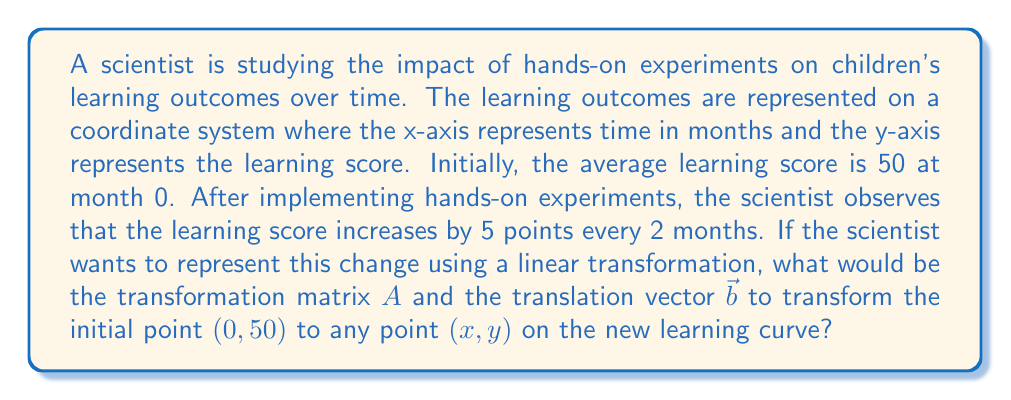Solve this math problem. Let's approach this step-by-step:

1) The general form of a linear transformation with translation is:

   $\begin{pmatrix} x' \\ y' \end{pmatrix} = A\begin{pmatrix} x \\ y \end{pmatrix} + \vec{b}$

   where $A$ is the transformation matrix and $\vec{b}$ is the translation vector.

2) We need to find the equation of the line representing the learning curve. We know:
   - The initial point is $(0, 50)$
   - The score increases by 5 points every 2 months

3) This gives us a slope of $\frac{5}{2} = 2.5$ points per month.

4) The equation of the line is therefore:
   $y = 2.5x + 50$

5) To represent this as a linear transformation:
   $\begin{pmatrix} x' \\ y' \end{pmatrix} = \begin{pmatrix} 1 & 0 \\ 2.5 & 1 \end{pmatrix}\begin{pmatrix} x \\ y \end{pmatrix} + \begin{pmatrix} 0 \\ 50 \end{pmatrix}$

6) Here's why:
   - The $x$ coordinate remains unchanged, so the first row of $A$ is $(1, 0)$
   - The $y$ coordinate increases by $2.5x$, so the second row of $A$ is $(2.5, 1)$
   - The initial $y$-intercept is 50, so $\vec{b} = (0, 50)$

Therefore, the transformation matrix $A$ and translation vector $\vec{b}$ are:

$A = \begin{pmatrix} 1 & 0 \\ 2.5 & 1 \end{pmatrix}$ and $\vec{b} = \begin{pmatrix} 0 \\ 50 \end{pmatrix}$
Answer: $A = \begin{pmatrix} 1 & 0 \\ 2.5 & 1 \end{pmatrix}$, $\vec{b} = \begin{pmatrix} 0 \\ 50 \end{pmatrix}$ 